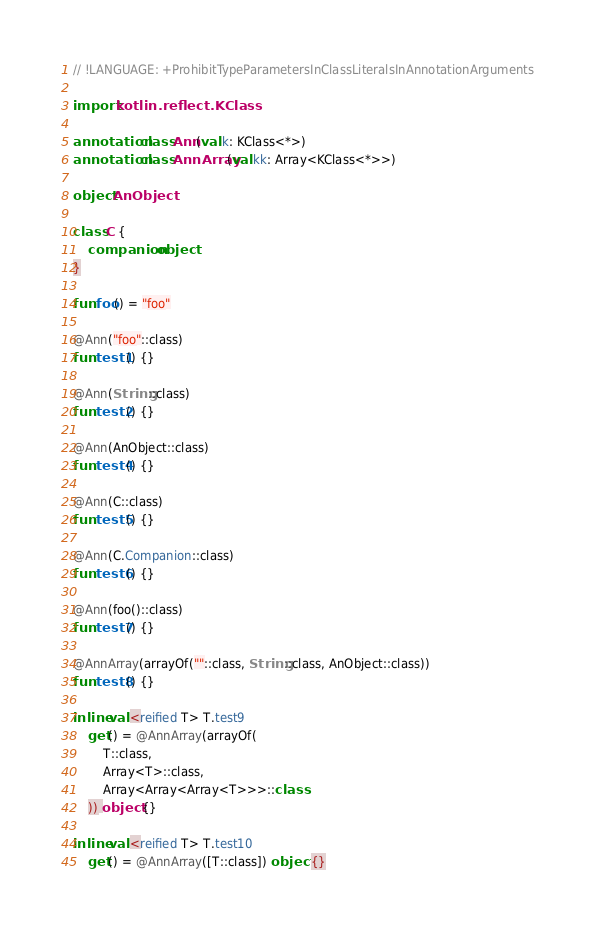Convert code to text. <code><loc_0><loc_0><loc_500><loc_500><_Kotlin_>// !LANGUAGE: +ProhibitTypeParametersInClassLiteralsInAnnotationArguments

import kotlin.reflect.KClass

annotation class Ann(val k: KClass<*>)
annotation class AnnArray(val kk: Array<KClass<*>>)

object AnObject

class C {
    companion object
}

fun foo() = "foo"

@Ann("foo"::class)
fun test1() {}

@Ann(String::class)
fun test2() {}

@Ann(AnObject::class)
fun test4() {}

@Ann(C::class)
fun test5() {}

@Ann(C.Companion::class)
fun test6() {}

@Ann(foo()::class)
fun test7() {}

@AnnArray(arrayOf(""::class, String::class, AnObject::class))
fun test8() {}

inline val <reified T> T.test9
    get() = @AnnArray(arrayOf(
        T::class,
        Array<T>::class,
        Array<Array<Array<T>>>::class
    )) object {}

inline val <reified T> T.test10
    get() = @AnnArray([T::class]) object {}
</code> 